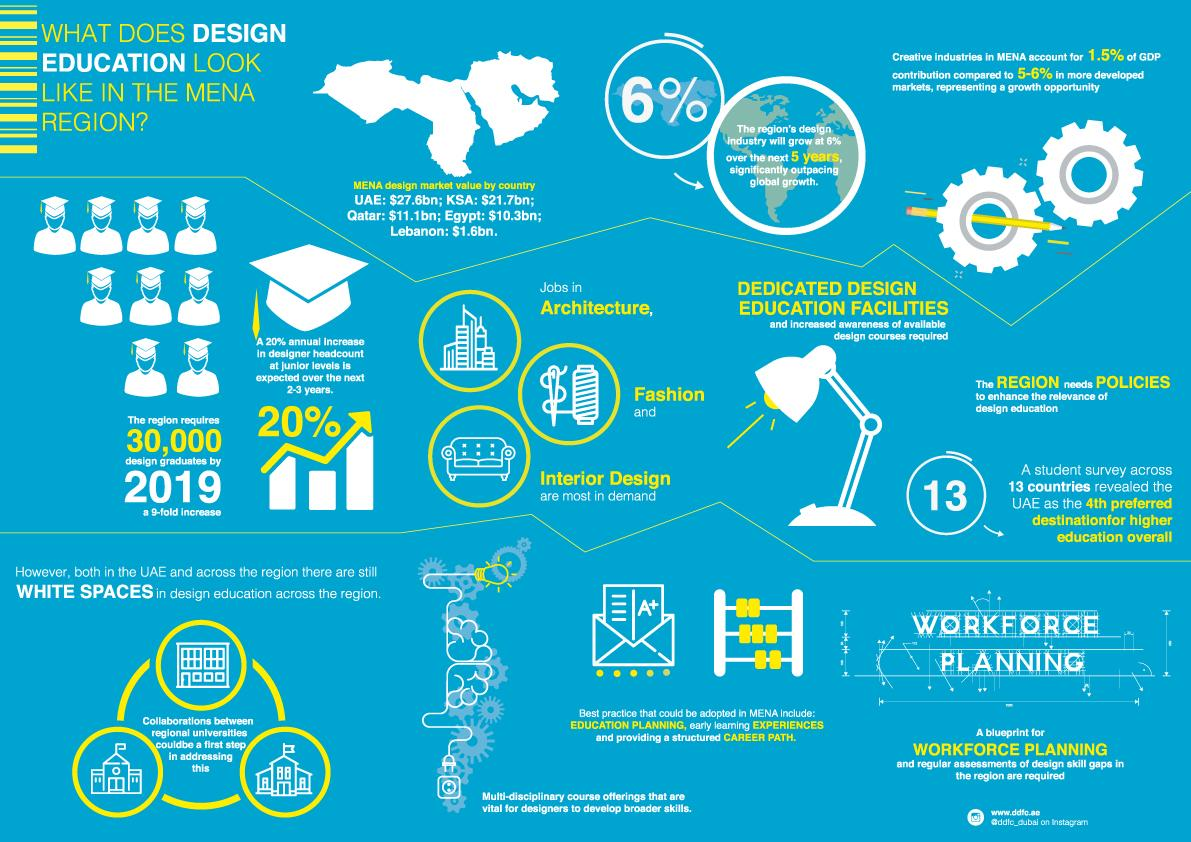Indicate a few pertinent items in this graphic. According to the provided information, the combined design market value for KSA and Lebanon is estimated to be $23.3 billion. The combined design market value for Saudi Arabia and Egypt is estimated to be $32 billion. 